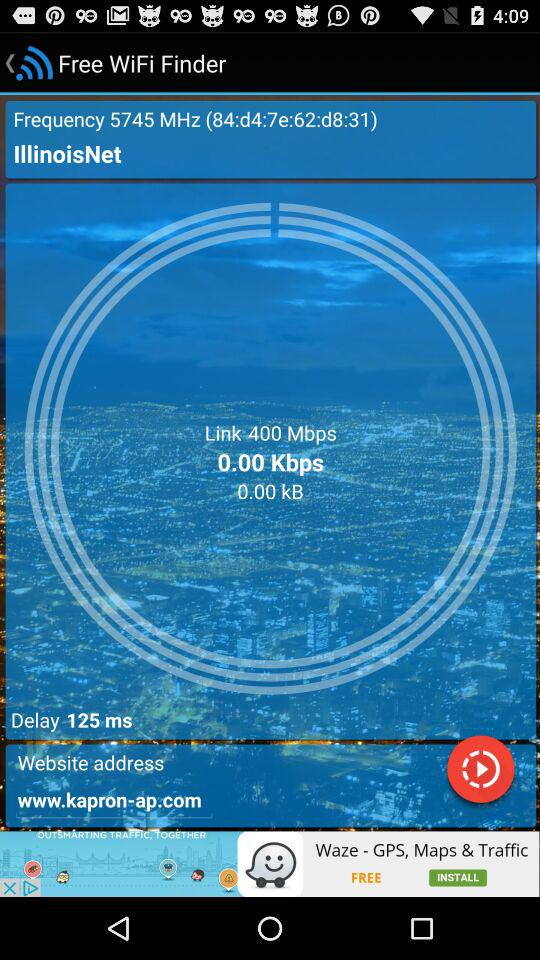What is the website address? The website address is www.kapron-ap.com. 